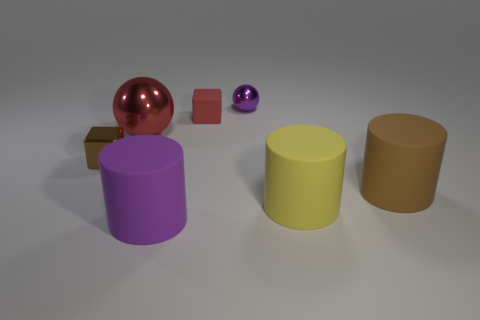The small red object that is behind the cylinder left of the small matte thing is made of what material?
Offer a terse response. Rubber. There is a small metal thing right of the big purple cylinder; is its shape the same as the brown rubber object?
Your answer should be very brief. No. What color is the small object that is made of the same material as the tiny purple sphere?
Provide a succinct answer. Brown. There is a brown object right of the large red ball; what is it made of?
Your answer should be compact. Rubber. Do the large red thing and the rubber thing to the left of the small matte cube have the same shape?
Ensure brevity in your answer.  No. There is a tiny thing that is both in front of the purple metallic object and behind the tiny brown cube; what material is it?
Offer a very short reply. Rubber. There is a shiny thing that is the same size as the purple sphere; what color is it?
Make the answer very short. Brown. Is the material of the tiny ball the same as the tiny cube that is in front of the tiny red rubber object?
Ensure brevity in your answer.  Yes. How many other objects are there of the same size as the brown rubber cylinder?
Your response must be concise. 3. There is a big rubber thing that is to the left of the red thing to the right of the big red metallic object; is there a small red block in front of it?
Ensure brevity in your answer.  No. 